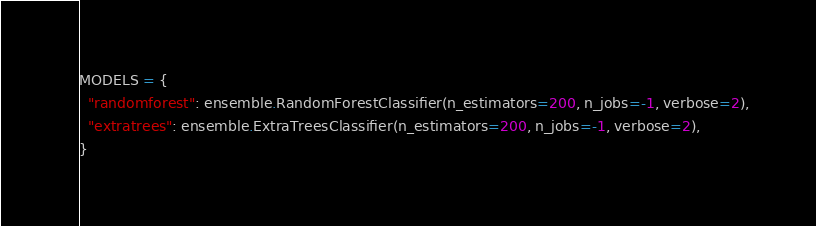<code> <loc_0><loc_0><loc_500><loc_500><_Python_>MODELS = {
  "randomforest": ensemble.RandomForestClassifier(n_estimators=200, n_jobs=-1, verbose=2),
  "extratrees": ensemble.ExtraTreesClassifier(n_estimators=200, n_jobs=-1, verbose=2),
}</code> 